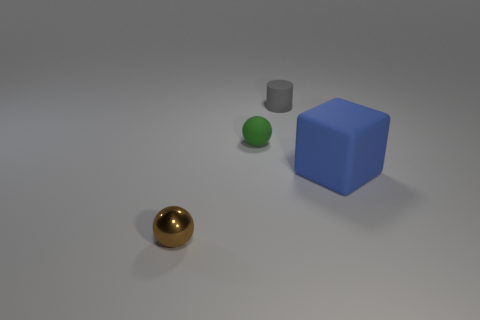Subtract all green spheres. How many spheres are left? 1 Add 1 blue objects. How many objects exist? 5 Subtract all cylinders. How many objects are left? 3 Subtract all metallic cylinders. Subtract all cubes. How many objects are left? 3 Add 2 gray cylinders. How many gray cylinders are left? 3 Add 2 cylinders. How many cylinders exist? 3 Subtract 1 blue blocks. How many objects are left? 3 Subtract all blue cylinders. Subtract all gray balls. How many cylinders are left? 1 Subtract all purple blocks. How many brown spheres are left? 1 